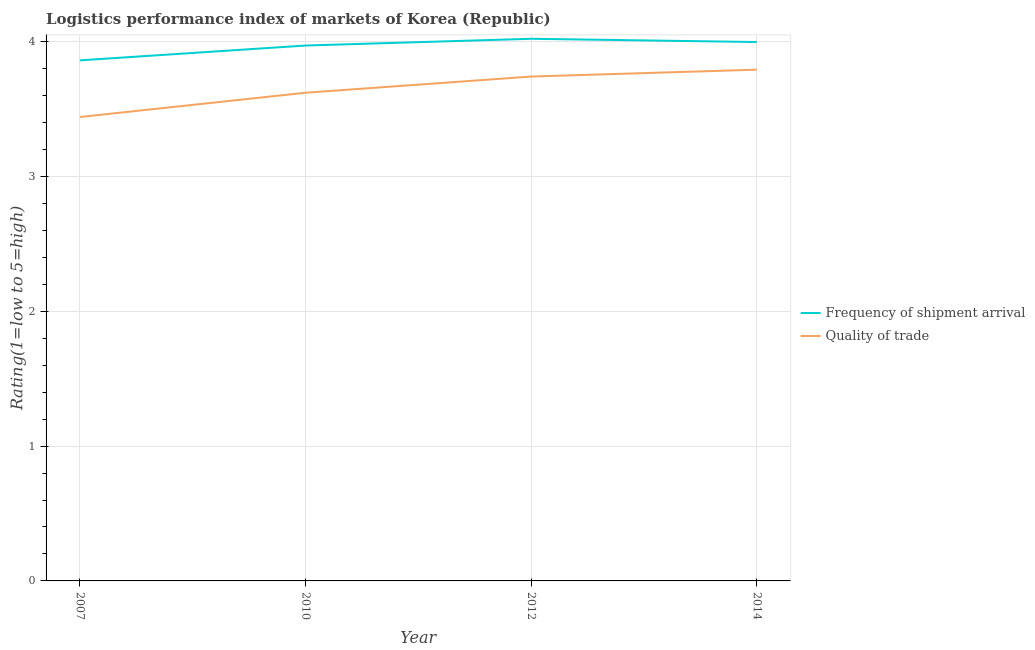How many different coloured lines are there?
Provide a succinct answer. 2. Is the number of lines equal to the number of legend labels?
Your answer should be very brief. Yes. What is the lpi of frequency of shipment arrival in 2010?
Offer a very short reply. 3.97. Across all years, what is the maximum lpi of frequency of shipment arrival?
Your answer should be compact. 4.02. Across all years, what is the minimum lpi quality of trade?
Offer a very short reply. 3.44. In which year was the lpi quality of trade minimum?
Your answer should be compact. 2007. What is the total lpi of frequency of shipment arrival in the graph?
Offer a terse response. 15.85. What is the difference between the lpi quality of trade in 2012 and that in 2014?
Make the answer very short. -0.05. What is the difference between the lpi of frequency of shipment arrival in 2012 and the lpi quality of trade in 2007?
Offer a terse response. 0.58. What is the average lpi of frequency of shipment arrival per year?
Ensure brevity in your answer.  3.96. In the year 2010, what is the difference between the lpi quality of trade and lpi of frequency of shipment arrival?
Make the answer very short. -0.35. What is the ratio of the lpi quality of trade in 2010 to that in 2012?
Your response must be concise. 0.97. Is the lpi quality of trade in 2010 less than that in 2014?
Offer a terse response. Yes. Is the difference between the lpi quality of trade in 2007 and 2012 greater than the difference between the lpi of frequency of shipment arrival in 2007 and 2012?
Offer a very short reply. No. What is the difference between the highest and the second highest lpi of frequency of shipment arrival?
Offer a terse response. 0.02. What is the difference between the highest and the lowest lpi quality of trade?
Provide a succinct answer. 0.35. In how many years, is the lpi of frequency of shipment arrival greater than the average lpi of frequency of shipment arrival taken over all years?
Your answer should be very brief. 3. Does the lpi quality of trade monotonically increase over the years?
Ensure brevity in your answer.  Yes. Is the lpi quality of trade strictly greater than the lpi of frequency of shipment arrival over the years?
Your response must be concise. No. Does the graph contain grids?
Provide a short and direct response. Yes. How are the legend labels stacked?
Make the answer very short. Vertical. What is the title of the graph?
Provide a short and direct response. Logistics performance index of markets of Korea (Republic). Does "Central government" appear as one of the legend labels in the graph?
Make the answer very short. No. What is the label or title of the X-axis?
Your response must be concise. Year. What is the label or title of the Y-axis?
Your answer should be very brief. Rating(1=low to 5=high). What is the Rating(1=low to 5=high) in Frequency of shipment arrival in 2007?
Your answer should be compact. 3.86. What is the Rating(1=low to 5=high) of Quality of trade in 2007?
Your answer should be compact. 3.44. What is the Rating(1=low to 5=high) of Frequency of shipment arrival in 2010?
Make the answer very short. 3.97. What is the Rating(1=low to 5=high) of Quality of trade in 2010?
Ensure brevity in your answer.  3.62. What is the Rating(1=low to 5=high) of Frequency of shipment arrival in 2012?
Your response must be concise. 4.02. What is the Rating(1=low to 5=high) in Quality of trade in 2012?
Make the answer very short. 3.74. What is the Rating(1=low to 5=high) in Frequency of shipment arrival in 2014?
Keep it short and to the point. 4. What is the Rating(1=low to 5=high) in Quality of trade in 2014?
Your answer should be compact. 3.79. Across all years, what is the maximum Rating(1=low to 5=high) of Frequency of shipment arrival?
Your response must be concise. 4.02. Across all years, what is the maximum Rating(1=low to 5=high) of Quality of trade?
Give a very brief answer. 3.79. Across all years, what is the minimum Rating(1=low to 5=high) in Frequency of shipment arrival?
Keep it short and to the point. 3.86. Across all years, what is the minimum Rating(1=low to 5=high) of Quality of trade?
Give a very brief answer. 3.44. What is the total Rating(1=low to 5=high) of Frequency of shipment arrival in the graph?
Provide a short and direct response. 15.85. What is the total Rating(1=low to 5=high) of Quality of trade in the graph?
Ensure brevity in your answer.  14.59. What is the difference between the Rating(1=low to 5=high) of Frequency of shipment arrival in 2007 and that in 2010?
Your answer should be very brief. -0.11. What is the difference between the Rating(1=low to 5=high) in Quality of trade in 2007 and that in 2010?
Give a very brief answer. -0.18. What is the difference between the Rating(1=low to 5=high) of Frequency of shipment arrival in 2007 and that in 2012?
Your answer should be compact. -0.16. What is the difference between the Rating(1=low to 5=high) of Quality of trade in 2007 and that in 2012?
Give a very brief answer. -0.3. What is the difference between the Rating(1=low to 5=high) of Frequency of shipment arrival in 2007 and that in 2014?
Make the answer very short. -0.14. What is the difference between the Rating(1=low to 5=high) in Quality of trade in 2007 and that in 2014?
Give a very brief answer. -0.35. What is the difference between the Rating(1=low to 5=high) of Frequency of shipment arrival in 2010 and that in 2012?
Offer a very short reply. -0.05. What is the difference between the Rating(1=low to 5=high) in Quality of trade in 2010 and that in 2012?
Provide a short and direct response. -0.12. What is the difference between the Rating(1=low to 5=high) in Frequency of shipment arrival in 2010 and that in 2014?
Give a very brief answer. -0.03. What is the difference between the Rating(1=low to 5=high) in Quality of trade in 2010 and that in 2014?
Provide a short and direct response. -0.17. What is the difference between the Rating(1=low to 5=high) of Frequency of shipment arrival in 2012 and that in 2014?
Your response must be concise. 0.02. What is the difference between the Rating(1=low to 5=high) in Quality of trade in 2012 and that in 2014?
Provide a succinct answer. -0.05. What is the difference between the Rating(1=low to 5=high) in Frequency of shipment arrival in 2007 and the Rating(1=low to 5=high) in Quality of trade in 2010?
Provide a succinct answer. 0.24. What is the difference between the Rating(1=low to 5=high) in Frequency of shipment arrival in 2007 and the Rating(1=low to 5=high) in Quality of trade in 2012?
Keep it short and to the point. 0.12. What is the difference between the Rating(1=low to 5=high) of Frequency of shipment arrival in 2007 and the Rating(1=low to 5=high) of Quality of trade in 2014?
Give a very brief answer. 0.07. What is the difference between the Rating(1=low to 5=high) of Frequency of shipment arrival in 2010 and the Rating(1=low to 5=high) of Quality of trade in 2012?
Ensure brevity in your answer.  0.23. What is the difference between the Rating(1=low to 5=high) of Frequency of shipment arrival in 2010 and the Rating(1=low to 5=high) of Quality of trade in 2014?
Provide a short and direct response. 0.18. What is the difference between the Rating(1=low to 5=high) of Frequency of shipment arrival in 2012 and the Rating(1=low to 5=high) of Quality of trade in 2014?
Your response must be concise. 0.23. What is the average Rating(1=low to 5=high) in Frequency of shipment arrival per year?
Your answer should be very brief. 3.96. What is the average Rating(1=low to 5=high) in Quality of trade per year?
Provide a succinct answer. 3.65. In the year 2007, what is the difference between the Rating(1=low to 5=high) in Frequency of shipment arrival and Rating(1=low to 5=high) in Quality of trade?
Give a very brief answer. 0.42. In the year 2010, what is the difference between the Rating(1=low to 5=high) of Frequency of shipment arrival and Rating(1=low to 5=high) of Quality of trade?
Ensure brevity in your answer.  0.35. In the year 2012, what is the difference between the Rating(1=low to 5=high) in Frequency of shipment arrival and Rating(1=low to 5=high) in Quality of trade?
Your answer should be very brief. 0.28. In the year 2014, what is the difference between the Rating(1=low to 5=high) of Frequency of shipment arrival and Rating(1=low to 5=high) of Quality of trade?
Your answer should be compact. 0.2. What is the ratio of the Rating(1=low to 5=high) of Frequency of shipment arrival in 2007 to that in 2010?
Keep it short and to the point. 0.97. What is the ratio of the Rating(1=low to 5=high) of Quality of trade in 2007 to that in 2010?
Make the answer very short. 0.95. What is the ratio of the Rating(1=low to 5=high) of Frequency of shipment arrival in 2007 to that in 2012?
Ensure brevity in your answer.  0.96. What is the ratio of the Rating(1=low to 5=high) in Quality of trade in 2007 to that in 2012?
Your response must be concise. 0.92. What is the ratio of the Rating(1=low to 5=high) of Frequency of shipment arrival in 2007 to that in 2014?
Keep it short and to the point. 0.97. What is the ratio of the Rating(1=low to 5=high) in Quality of trade in 2007 to that in 2014?
Offer a terse response. 0.91. What is the ratio of the Rating(1=low to 5=high) of Frequency of shipment arrival in 2010 to that in 2012?
Your answer should be very brief. 0.99. What is the ratio of the Rating(1=low to 5=high) in Quality of trade in 2010 to that in 2012?
Your answer should be compact. 0.97. What is the ratio of the Rating(1=low to 5=high) in Frequency of shipment arrival in 2010 to that in 2014?
Your answer should be very brief. 0.99. What is the ratio of the Rating(1=low to 5=high) of Quality of trade in 2010 to that in 2014?
Offer a very short reply. 0.95. What is the ratio of the Rating(1=low to 5=high) in Quality of trade in 2012 to that in 2014?
Ensure brevity in your answer.  0.99. What is the difference between the highest and the second highest Rating(1=low to 5=high) of Frequency of shipment arrival?
Ensure brevity in your answer.  0.02. What is the difference between the highest and the second highest Rating(1=low to 5=high) of Quality of trade?
Keep it short and to the point. 0.05. What is the difference between the highest and the lowest Rating(1=low to 5=high) of Frequency of shipment arrival?
Ensure brevity in your answer.  0.16. What is the difference between the highest and the lowest Rating(1=low to 5=high) of Quality of trade?
Give a very brief answer. 0.35. 